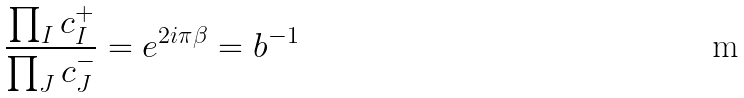Convert formula to latex. <formula><loc_0><loc_0><loc_500><loc_500>\frac { \prod _ { I } c _ { I } ^ { + } } { \prod _ { J } c _ { J } ^ { - } } = e ^ { 2 i \pi \beta } = b ^ { - 1 }</formula> 